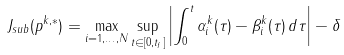<formula> <loc_0><loc_0><loc_500><loc_500>J _ { s u b } ( p ^ { k , * } ) = \max _ { i = 1 , \dots , N } \sup _ { t \in [ 0 , t _ { f } ] } \left | \int _ { 0 } ^ { t } \alpha _ { i } ^ { k } ( \tau ) - \beta _ { i } ^ { k } ( \tau ) \, d \tau \right | - \delta</formula> 